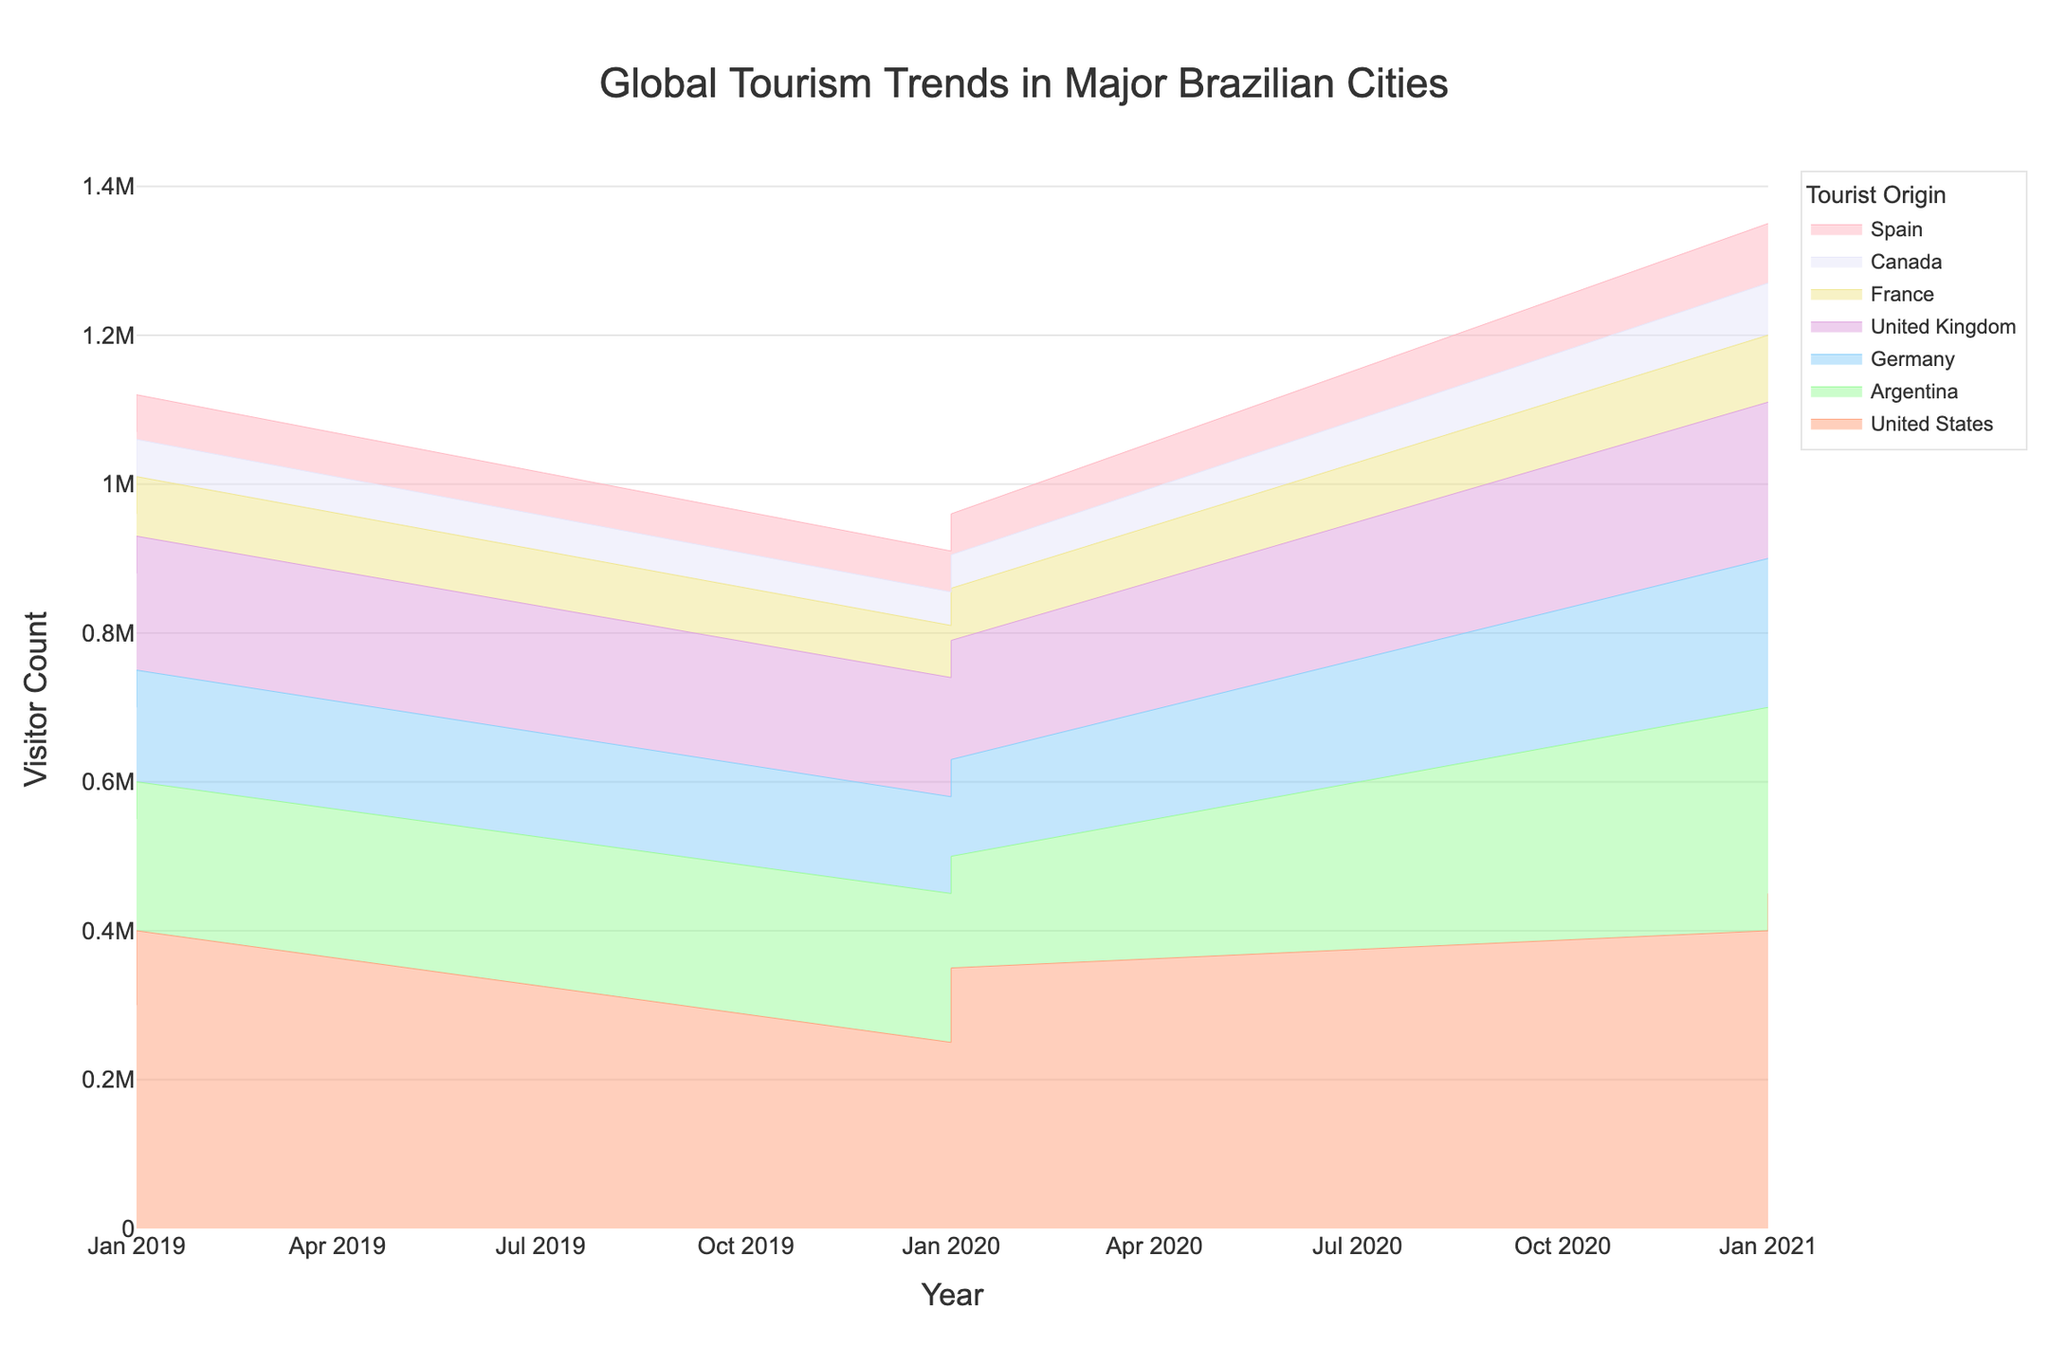Which city had the highest number of tourists from the United States in 2021? To find the city with the highest number of tourists from the United States in 2021, locate the data points for the United States, and look for the year 2021. Check the height of the points on the y-axis for each city. Sao Paulo has the highest peak in 2021 for the United States.
Answer: Sao Paulo How did the number of tourists from Argentina to Rio de Janeiro change from 2019 to 2021? To determine the change, find the segments for Argentina in Rio de Janeiro for the years 2019 and 2021, and compare their heights on the y-axis. The number of tourists increased from 250,000 in 2019 to 300,000 in 2021.
Answer: Increased by 50,000 What is the total number of tourists from Germany to Rio de Janeiro in the years shown? Sum the Visitor_Count for Germany in Rio de Janeiro across all available years (150,000 in 2019, 130,000 in 2020, 200,000 in 2021). 150,000 + 130,000 + 200,000 = 480,000.
Answer: 480,000 Which tourist origin group experienced the largest overall increase in visitor counts to Brazilian cities from 2019 to 2021? Examine the height of the stream for each Tourist Origin from 2019 to 2021 and identify the one with the largest growth. The United States stream shows the largest increase in height, indicating the highest growth.
Answer: United States Compare the number of visitors from the United Kingdom to Sao Paulo in 2020 and 2021. Which year had higher numbers? Locate the segments for the United Kingdom in Sao Paulo for 2020 and 2021, then compare the heights on the y-axis. 2021 has a taller segment than 2020, indicating higher numbers in 2021.
Answer: 2021 In which year did Salvador experience its highest number of tourists from Spain? Identify the segments for Spain in Salvador and determine which year's segment is highest. The tallest segment appears in 2021.
Answer: 2021 For 2019 in Rio de Janeiro, which country contributed the second-highest number of tourists? Examine the streams for Rio de Janeiro for the year 2019 and compare the heights. The second tallest segment is Argentina after the United States.
Answer: Argentina What is the combined number of visitors from Canada to Salvador over all the years shown? Add the Visitor_Count for Canada in Salvador for the years 2019, 2020, and 2021. 50,000 + 45,000 + 70,000 = 165,000.
Answer: 165,000 